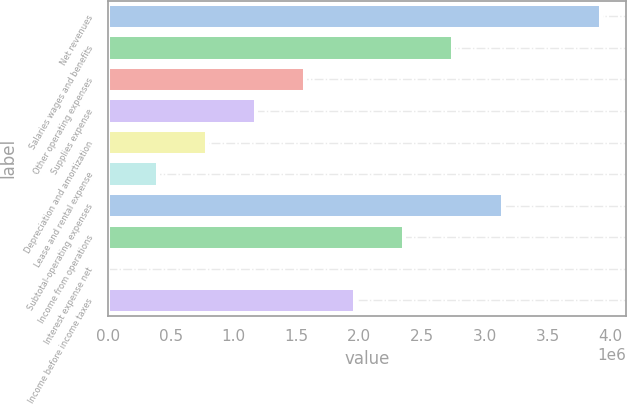Convert chart. <chart><loc_0><loc_0><loc_500><loc_500><bar_chart><fcel>Net revenues<fcel>Salaries wages and benefits<fcel>Other operating expenses<fcel>Supplies expense<fcel>Depreciation and amortization<fcel>Lease and rental expense<fcel>Subtotal-operating expenses<fcel>Income from operations<fcel>Interest expense net<fcel>Income before income taxes<nl><fcel>3.92767e+06<fcel>2.74994e+06<fcel>1.57222e+06<fcel>1.17964e+06<fcel>787067<fcel>394492<fcel>3.14252e+06<fcel>2.35737e+06<fcel>1917<fcel>1.96479e+06<nl></chart> 